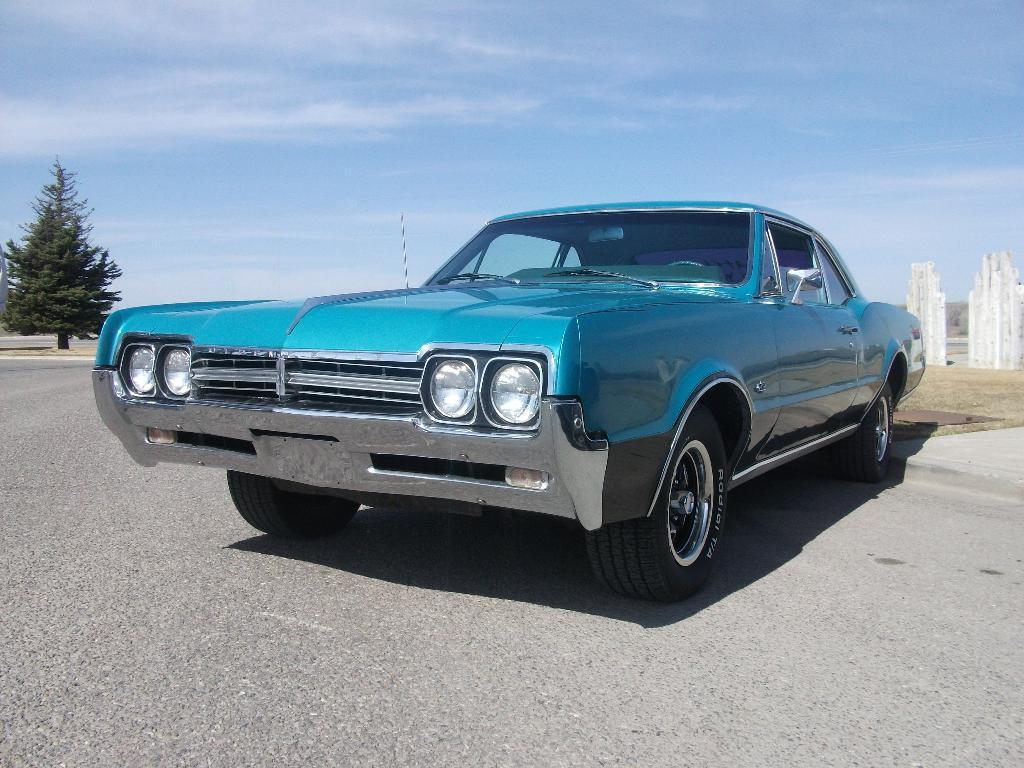What is the main subject of the image? The main subject of the image is a car on the road. What can be seen in the background of the image? There are structures visible in the background of the image. What type of vegetation is on the left side of the image? There is a tree on the left side of the image. What is visible at the top of the image? The sky is visible at the top of the image. Where is the boy sitting in the car in the image? There is no boy present in the image; it only features a car on the road. 